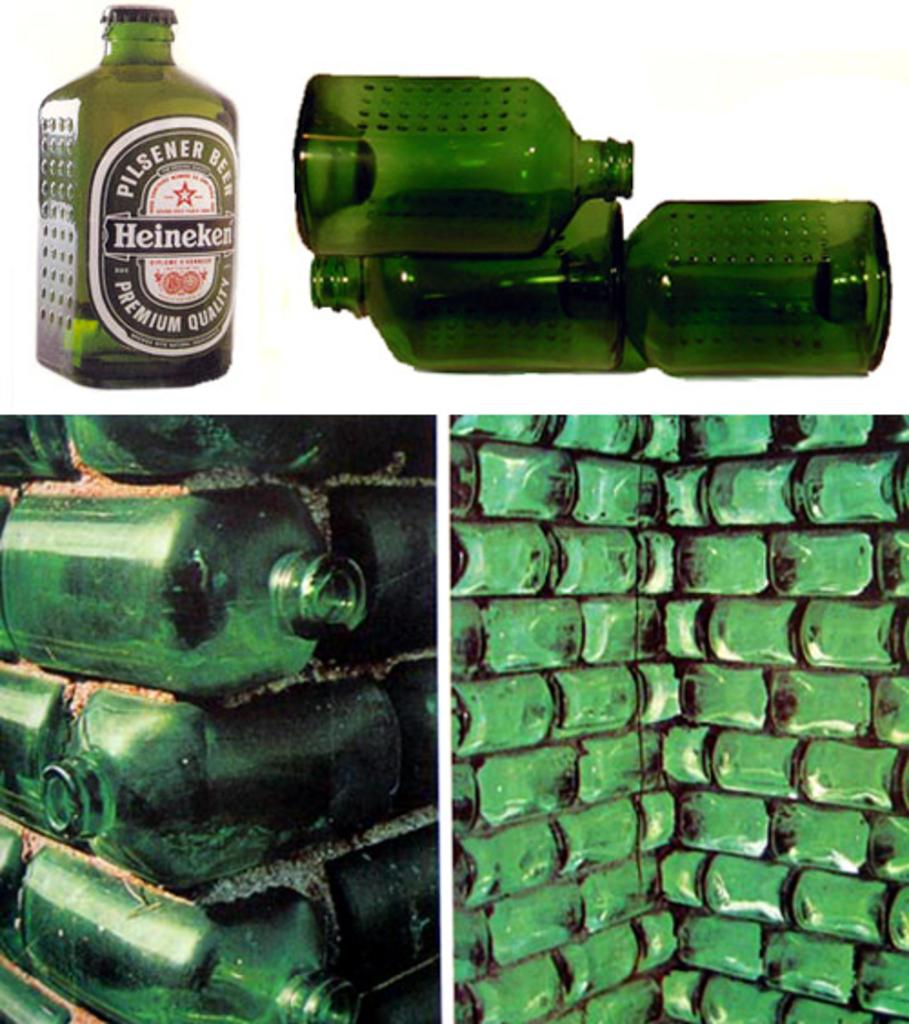What is the main subject of the image? The main subject of the image is a collage of pictures. Are there any specific objects featured in the collage? The provided facts do not mention any specific objects within the collage. What other items can be seen in the image besides the collage? There are green bottles in the image. What type of produce is being harvested from the roof in the image? There is no produce or roof present in the image; it features a collage of pictures and green bottles. 